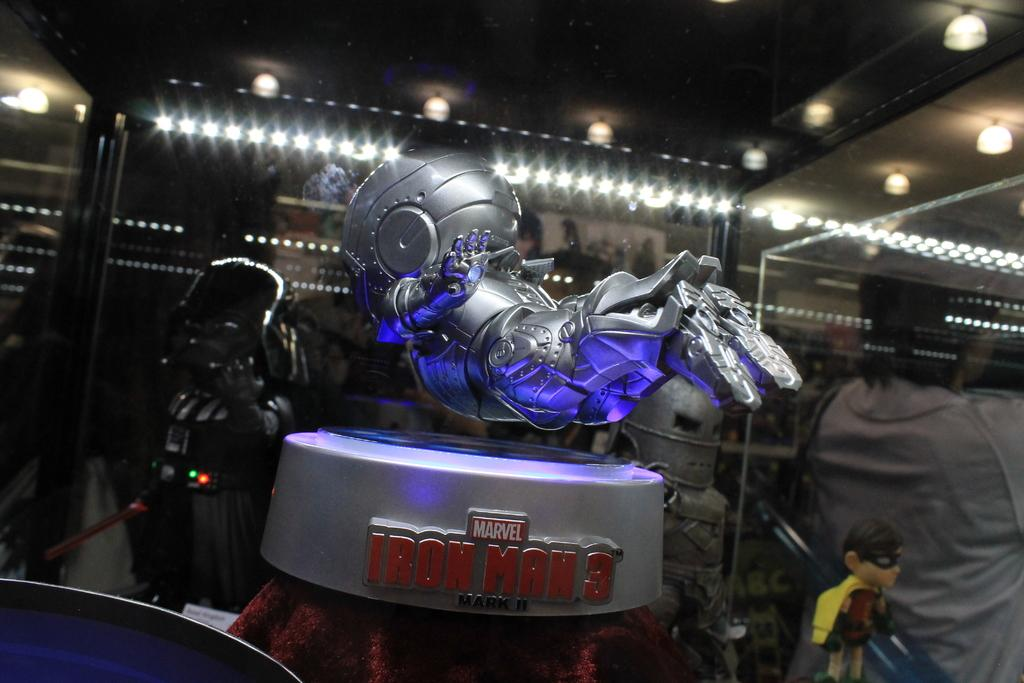What is the main subject of the image? There is a robot in the image. Can you describe the lighting in the image? There are lights in the ceiling in the background of the image. What type of theory does the robot propose in the image? There is no indication in the image that the robot is proposing a theory. How many hands does the robot have in the image? The image does not show the robot's hands, so it cannot be determined from the image. 